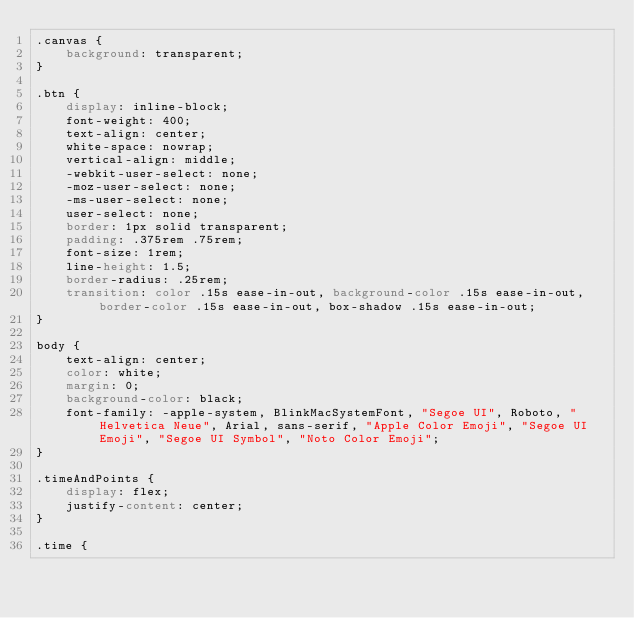Convert code to text. <code><loc_0><loc_0><loc_500><loc_500><_CSS_>.canvas {
    background: transparent;
}

.btn {
    display: inline-block;
    font-weight: 400;
    text-align: center;
    white-space: nowrap;
    vertical-align: middle;
    -webkit-user-select: none;
    -moz-user-select: none;
    -ms-user-select: none;
    user-select: none;
    border: 1px solid transparent;
    padding: .375rem .75rem;
    font-size: 1rem;
    line-height: 1.5;
    border-radius: .25rem;
    transition: color .15s ease-in-out, background-color .15s ease-in-out, border-color .15s ease-in-out, box-shadow .15s ease-in-out;
}

body {
    text-align: center;
    color: white;
    margin: 0;
    background-color: black;
    font-family: -apple-system, BlinkMacSystemFont, "Segoe UI", Roboto, "Helvetica Neue", Arial, sans-serif, "Apple Color Emoji", "Segoe UI Emoji", "Segoe UI Symbol", "Noto Color Emoji";
}

.timeAndPoints {
    display: flex;
    justify-content: center;
}

.time {</code> 